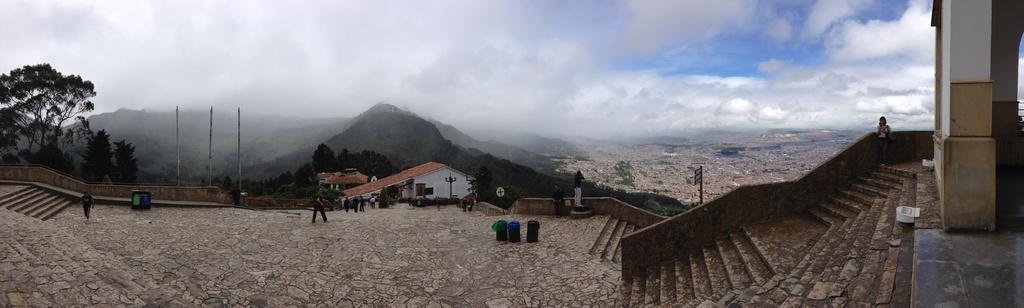Describe this image in one or two sentences. There are few people standing. I think these are the dustbins. I can see the stairs. I can see the trees and mountains. I think these are the houses. On the right side of the image, I can see a pillar. These are the clouds in the sky. I think here is the view of the city. 